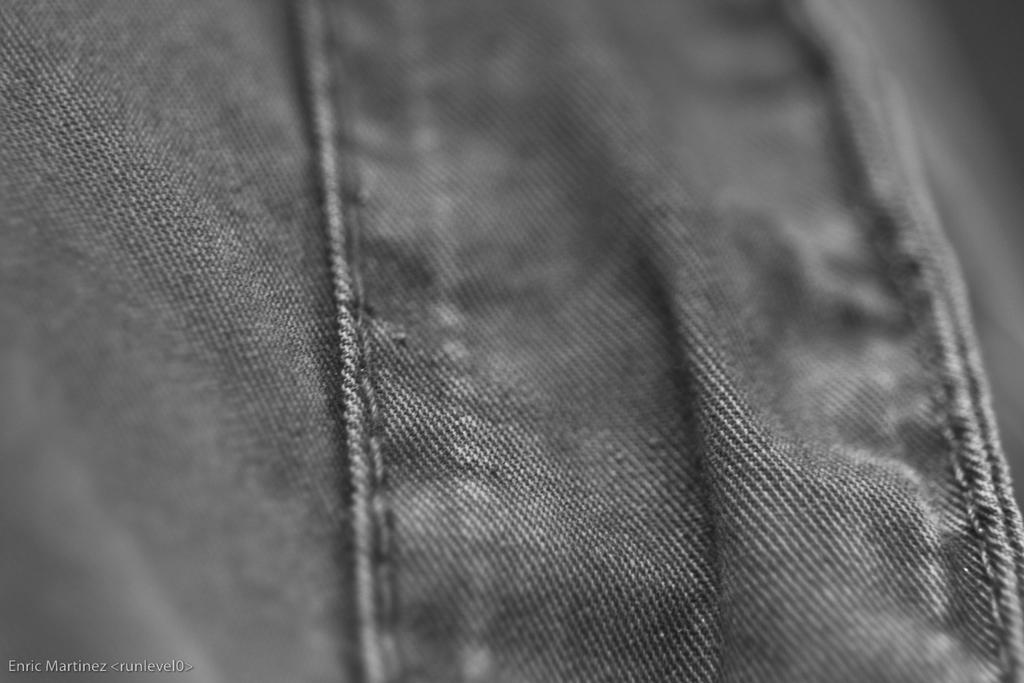What type of clothing is featured in the image? There is a pair of jeans in the image. Is there any text present in the image? Yes, there is some text at the bottom left side of the image. Can you see a circle swinging near a lake in the image? No, there is no circle, swing, or lake present in the image. 